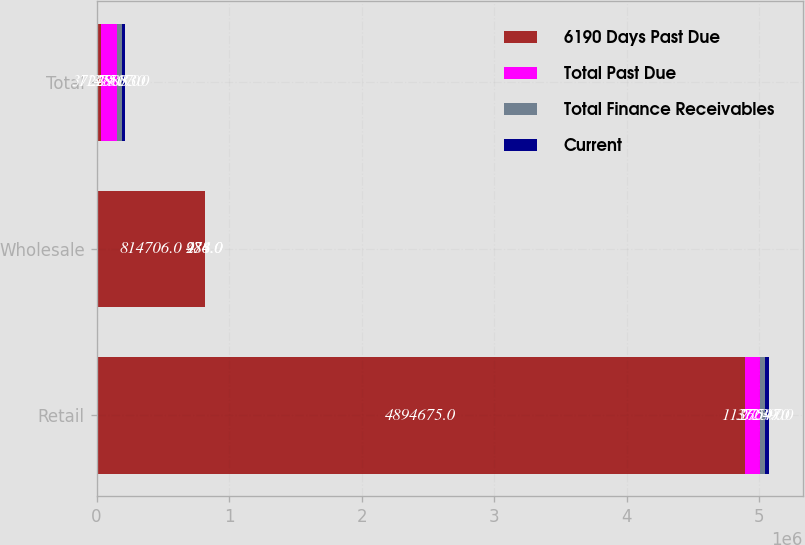Convert chart. <chart><loc_0><loc_0><loc_500><loc_500><stacked_bar_chart><ecel><fcel>Retail<fcel>Wholesale<fcel>Total<nl><fcel>6190 Days Past Due<fcel>4.89468e+06<fcel>814706<fcel>37239<nl><fcel>Total Past Due<fcel>113604<fcel>984<fcel>114588<nl><fcel>Total Finance Receivables<fcel>37239<fcel>278<fcel>37517<nl><fcel>Current<fcel>27597<fcel>436<fcel>28033<nl></chart> 